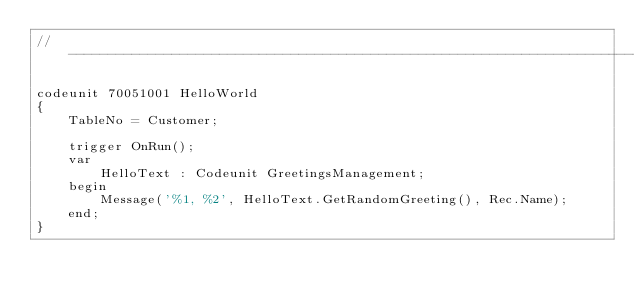Convert code to text. <code><loc_0><loc_0><loc_500><loc_500><_Perl_>// ------------------------------------------------------------------------------------------------

codeunit 70051001 HelloWorld
{
    TableNo = Customer;

    trigger OnRun();
    var
        HelloText : Codeunit GreetingsManagement;
    begin
        Message('%1, %2', HelloText.GetRandomGreeting(), Rec.Name);
    end;
}</code> 